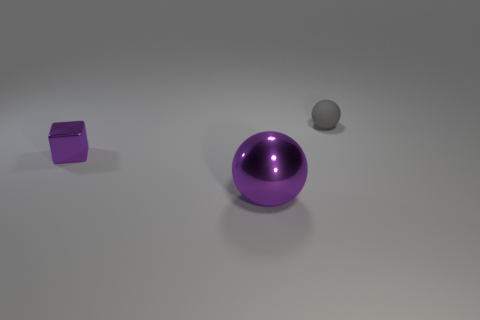Subtract all balls. How many objects are left? 1 Subtract all blue balls. Subtract all yellow blocks. How many balls are left? 2 Subtract all big yellow metal balls. Subtract all metallic things. How many objects are left? 1 Add 2 big purple spheres. How many big purple spheres are left? 3 Add 2 yellow metallic objects. How many yellow metallic objects exist? 2 Add 1 green metal balls. How many objects exist? 4 Subtract 1 purple blocks. How many objects are left? 2 Subtract 2 spheres. How many spheres are left? 0 Subtract all red blocks. How many brown balls are left? 0 